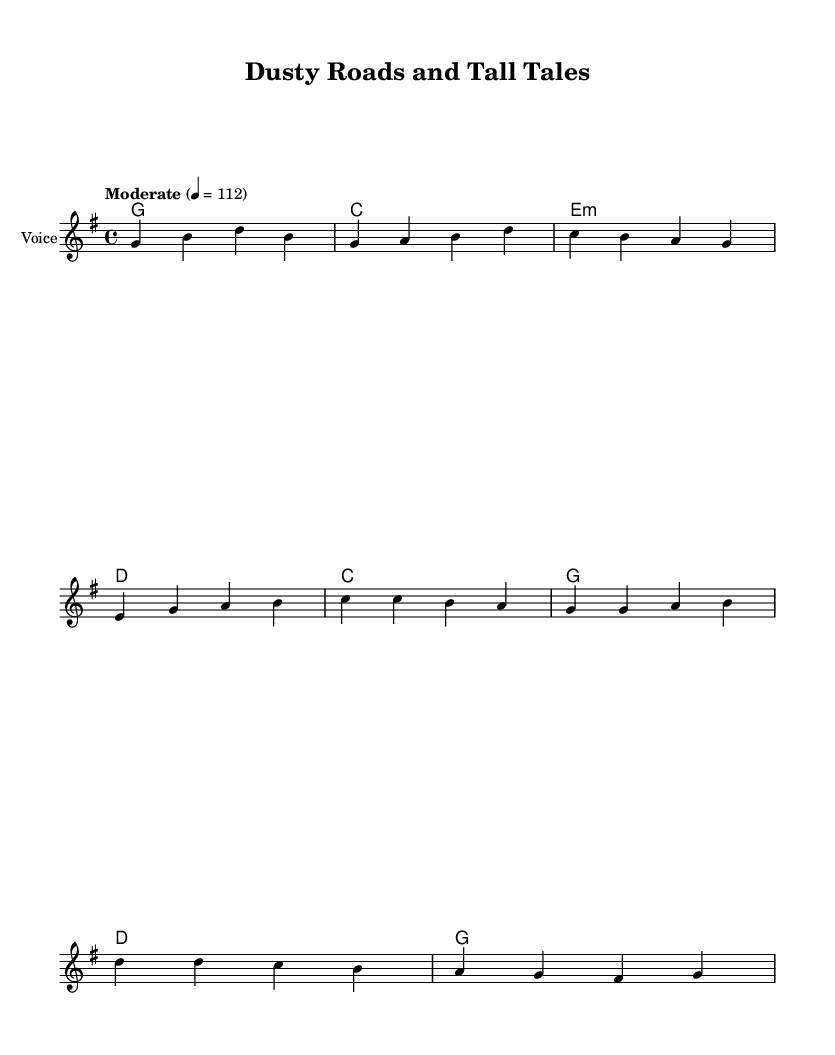What is the title of this music? The title is found in the header of the sheet music under the 'title' section.
Answer: Dusty Roads and Tall Tales What is the key signature of this music? The key signature is indicated at the beginning of the staff and is G major, which has one sharp (F#).
Answer: G major What is the time signature of this music? The time signature is defined next to the key signature at the beginning of the piece and is 4/4, indicating four beats per measure.
Answer: 4/4 What is the tempo marking for this piece? The tempo marking is found in the global section and is indicated as "Moderate" with a metronome mark of 112 beats per minute.
Answer: Moderate How many measures are in the verse section? To find this, count the individual measures notated in the melody line for the verse. There are four measures in the verse.
Answer: 4 What is the chord progression for the chorus? The chord progression can be determined by looking at the harmonies section for the chords that correspond to the chorus lyrics. The progression is C, G, D, G.
Answer: C, G, D, G Which local legend is mentioned in the song? The specific local legend mentioned in the lyrics is that of Bigfoot, as referenced by old man Johnson.
Answer: Bigfoot 